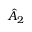Convert formula to latex. <formula><loc_0><loc_0><loc_500><loc_500>\hat { A } _ { 2 }</formula> 